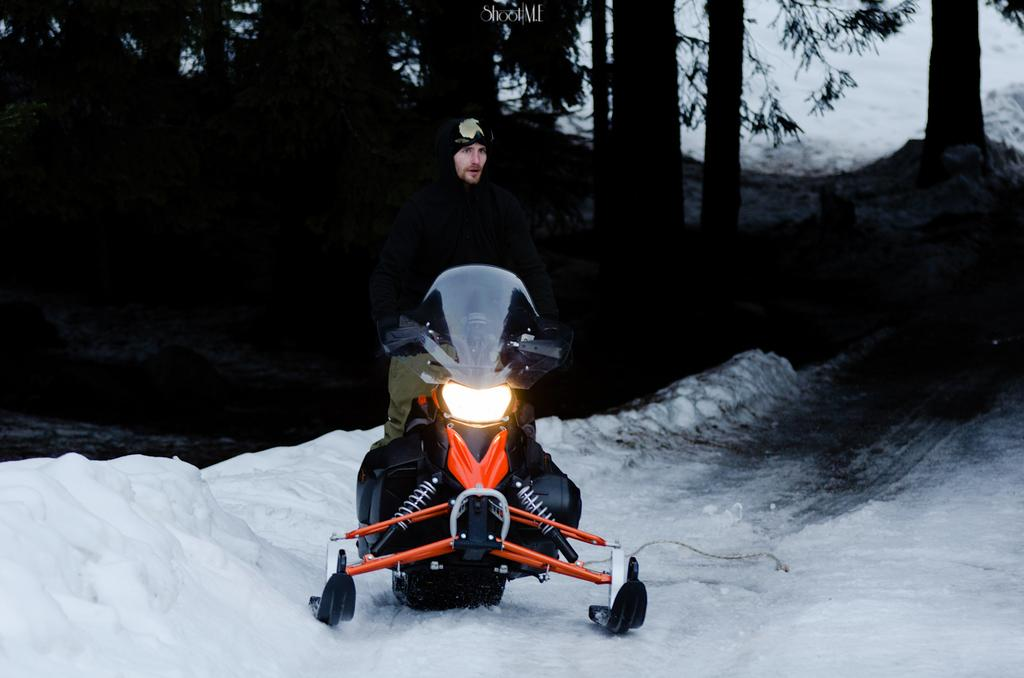Who or what is in the image? There is a person in the image. What is the person doing in the image? The person is standing with a snow bike. Where is the snow bike located in the image? The snow bike is on the snow. What can be seen in the background of the image? There are trees and snow in the background of the image. Is there any additional information about the image itself? Yes, there is a watermark on the image. How many pages are visible in the image? There are no pages present in the image; it is a photograph of a person with a snow bike. What type of shoes is the person wearing in the image? The image does not show the person's feet, so it is not possible to determine the type of shoes they are wearing. 